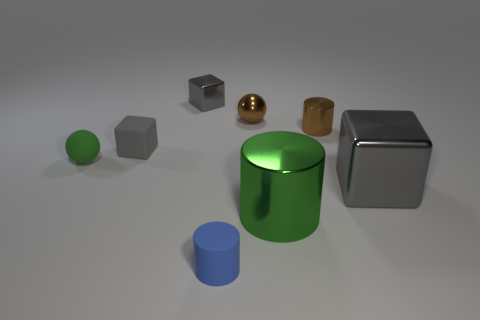Are any tiny cyan things visible? no 